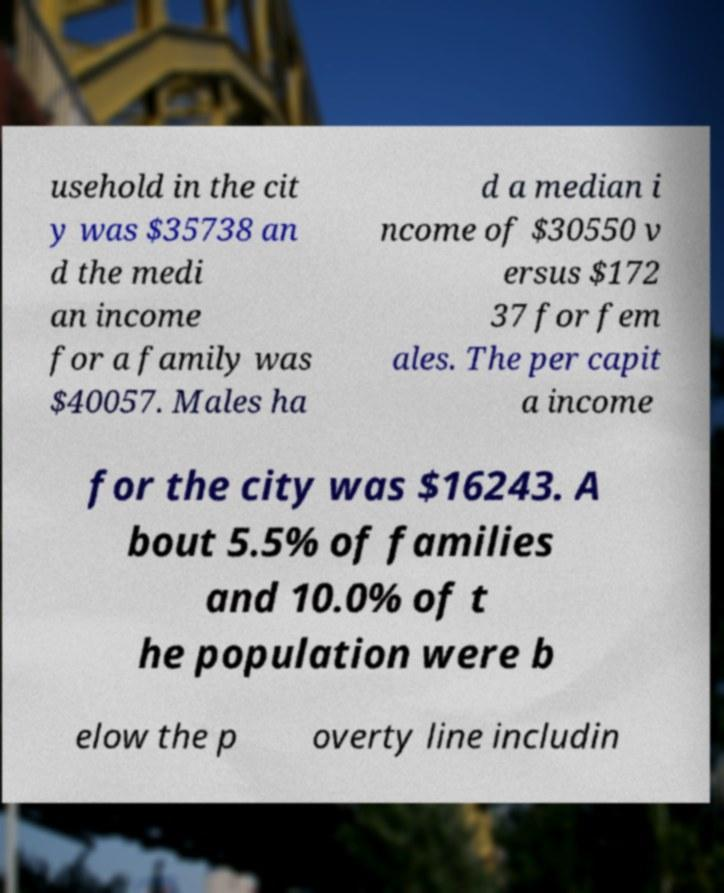What messages or text are displayed in this image? I need them in a readable, typed format. usehold in the cit y was $35738 an d the medi an income for a family was $40057. Males ha d a median i ncome of $30550 v ersus $172 37 for fem ales. The per capit a income for the city was $16243. A bout 5.5% of families and 10.0% of t he population were b elow the p overty line includin 